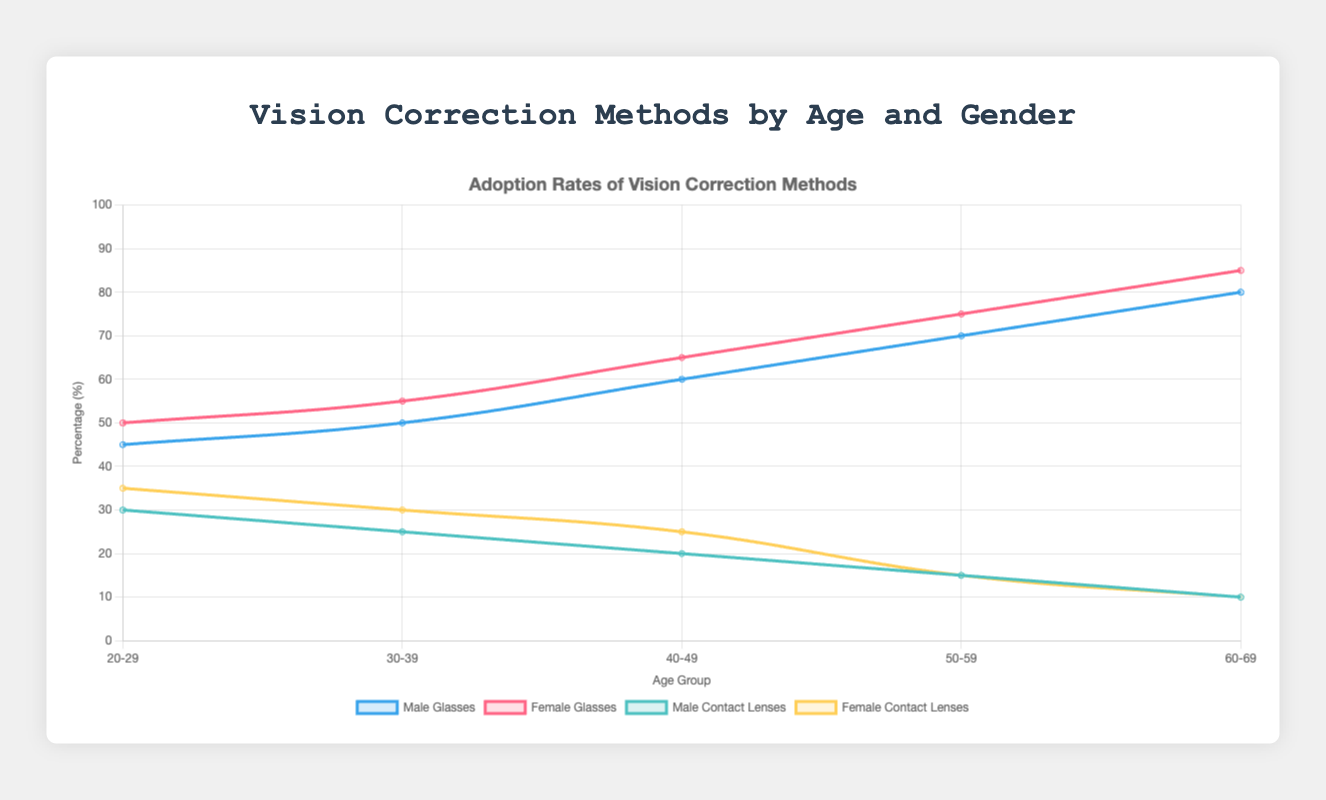What are the percentages of males wearing glasses in the age groups 20-29 and 60-69? In the age group 20-29, males wearing glasses constitute 45% of the group; in the age group 60-69, males wearing glasses constitute 80% of the group.
Answer: 45% and 80% In which age group do females have the highest percentage of contact lens usage? By comparing the contact lens data for females across all age groups, the highest percentage of usage is in the 20-29 age group at 35%.
Answer: 20-29 Who has a higher percentage of individuals using glasses in the age group 40-49, males or females? For the age group 40-49, males have a percentage of 60% while females have a percentage of 65%. Thus, females have a higher percentage using glasses.
Answer: Females Are there any age groups where the percentage of males using contact lenses is higher than that of females? By checking each age group, males always have a lower percentage of contact lens usage compared to females.
Answer: No What is the range in the percentage of people not using any vision correction method among all the age groups for males? The range is calculated by subtracting the minimum value from the maximum value for males: 20% (age group 20-29) - 5% (age group 60-69) = 15%.
Answer: 15% Do both males and females show an increase in glasses usage as they age? By observing the trend in the data, both males and females show an increase in the percentage of glasses usage from the age group 20-29 to 60-69.
Answer: Yes What is the sum of the contact lens usage percentages for males across all age groups? Adding up the contact lens usage percentages for males: 30 + 25 + 20 + 15 + 10 = 100.
Answer: 100% Comparing surgery rates between males and females, in which age groups do males have a higher surgery rate? By comparing surgery rates in each age group, males have higher rates in 20-29 (5% vs 8%), 40-49 (10% vs 7%), and 50-59 (8% vs 5%).
Answer: 20-29, 40-49, 50-59 Which gender has the lowest percentage of individuals not using any vision correction method in the age group 30-39? For the age group 30-39, females have a lower percentage not using any vision correction method at 5% compared to males at 18%.
Answer: Females What is the difference in the percentage of females using glasses between the age groups 50-59 and 30-39? Subtracting the percentage of females using glasses in the age group 30-39 from the percentage in the age group 50-59: 75% - 55% = 20%.
Answer: 20% 